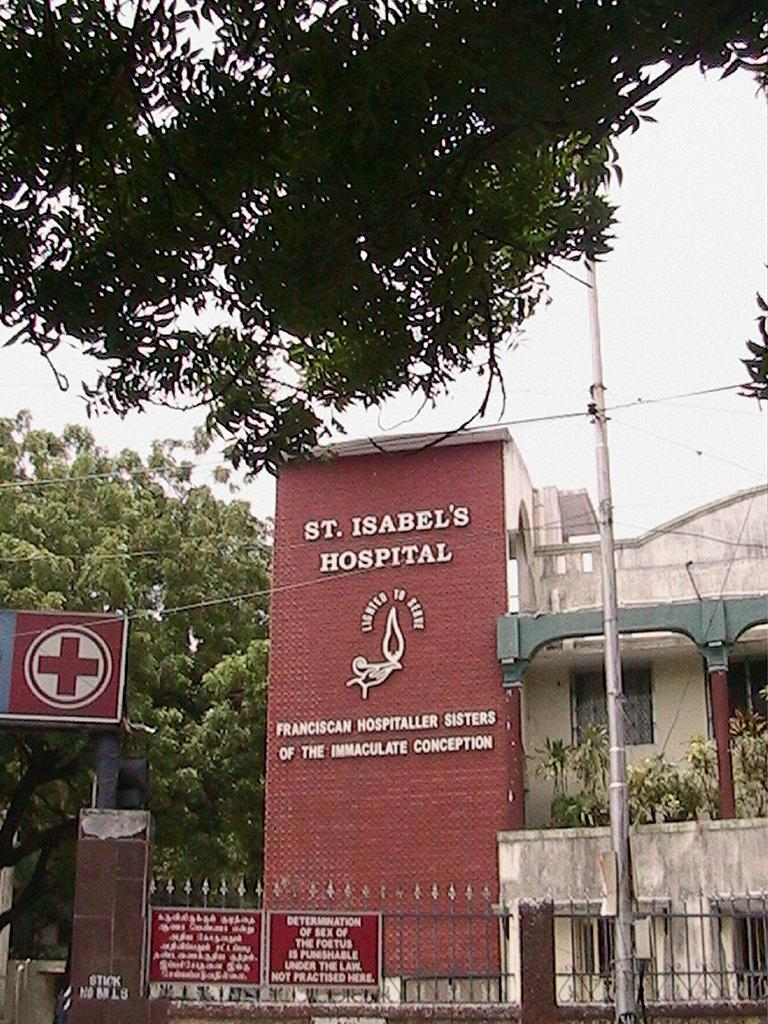What type of structures can be seen in the image? There are buildings in the image. What other natural elements are present in the image? There are plants and trees in the image. What type of barrier can be seen in the image? There is a fence in the image. What is visible at the top of the image? The sky is visible at the top of the image. Can you tell me how many veins are visible in the image? There are no veins present in the image; it features buildings, plants, trees, a fence, and the sky. What type of clouds can be seen in the image? The provided facts do not mention clouds; only the sky is mentioned as being visible at the top of the image. 